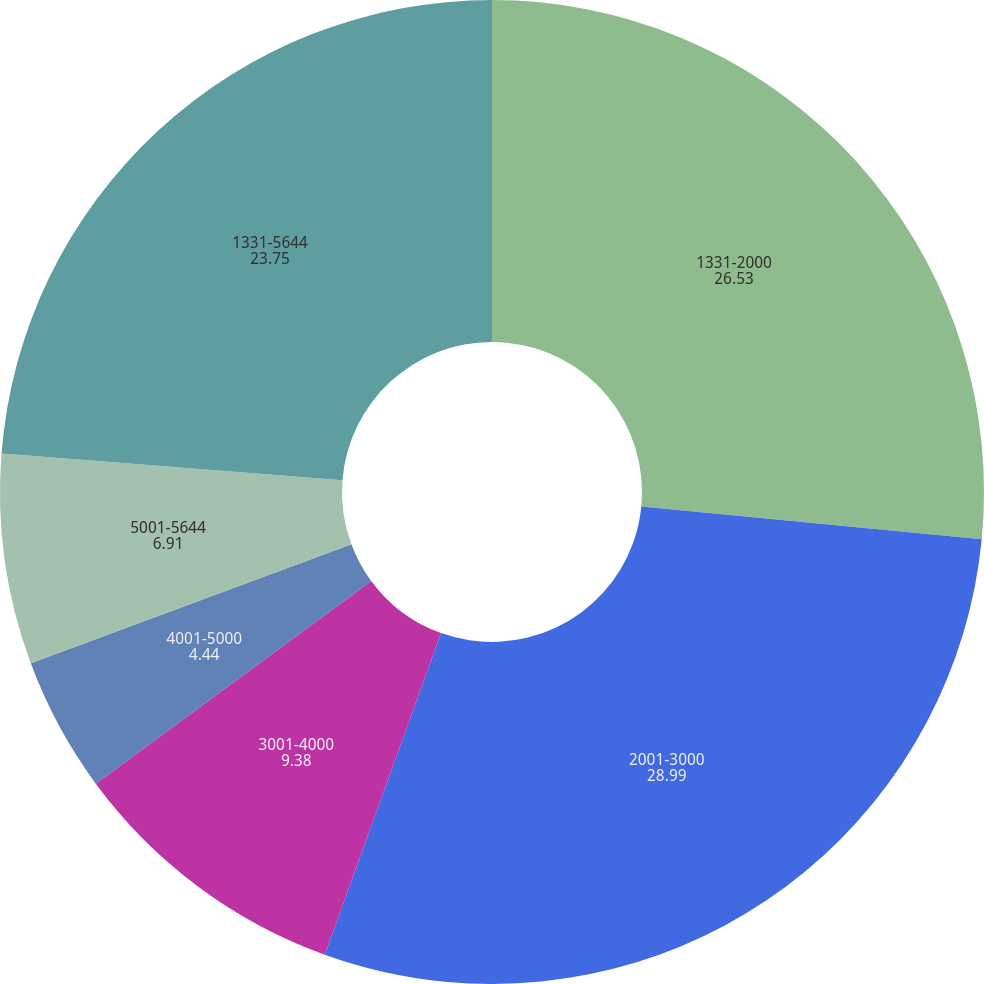Convert chart. <chart><loc_0><loc_0><loc_500><loc_500><pie_chart><fcel>1331-2000<fcel>2001-3000<fcel>3001-4000<fcel>4001-5000<fcel>5001-5644<fcel>1331-5644<nl><fcel>26.53%<fcel>28.99%<fcel>9.38%<fcel>4.44%<fcel>6.91%<fcel>23.75%<nl></chart> 